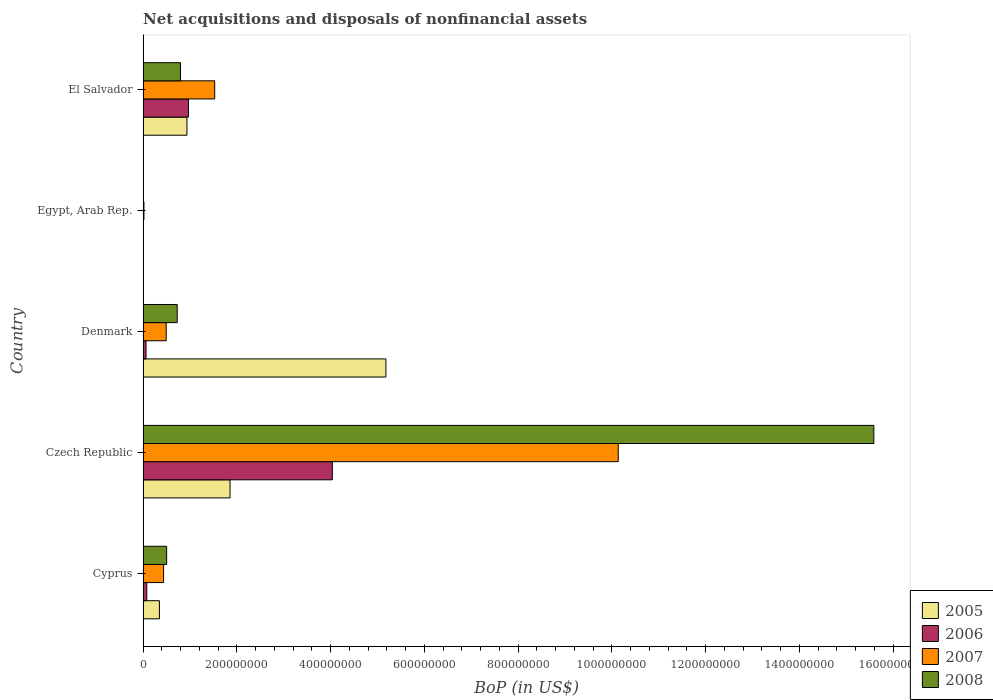How many different coloured bars are there?
Provide a short and direct response. 4. Are the number of bars per tick equal to the number of legend labels?
Keep it short and to the point. No. How many bars are there on the 1st tick from the top?
Keep it short and to the point. 4. How many bars are there on the 2nd tick from the bottom?
Ensure brevity in your answer.  4. What is the label of the 5th group of bars from the top?
Provide a short and direct response. Cyprus. In how many cases, is the number of bars for a given country not equal to the number of legend labels?
Offer a very short reply. 1. Across all countries, what is the maximum Balance of Payments in 2006?
Your answer should be compact. 4.04e+08. Across all countries, what is the minimum Balance of Payments in 2007?
Make the answer very short. 1.90e+06. In which country was the Balance of Payments in 2008 maximum?
Keep it short and to the point. Czech Republic. What is the total Balance of Payments in 2008 in the graph?
Your response must be concise. 1.76e+09. What is the difference between the Balance of Payments in 2007 in Denmark and that in El Salvador?
Your answer should be compact. -1.03e+08. What is the difference between the Balance of Payments in 2006 in Egypt, Arab Rep. and the Balance of Payments in 2008 in El Salvador?
Give a very brief answer. -7.98e+07. What is the average Balance of Payments in 2006 per country?
Offer a very short reply. 1.03e+08. What is the difference between the Balance of Payments in 2006 and Balance of Payments in 2008 in Cyprus?
Your answer should be compact. -4.24e+07. In how many countries, is the Balance of Payments in 2007 greater than 1560000000 US$?
Make the answer very short. 0. What is the ratio of the Balance of Payments in 2008 in Cyprus to that in Denmark?
Ensure brevity in your answer.  0.69. Is the Balance of Payments in 2006 in Czech Republic less than that in Denmark?
Ensure brevity in your answer.  No. Is the difference between the Balance of Payments in 2006 in Czech Republic and El Salvador greater than the difference between the Balance of Payments in 2008 in Czech Republic and El Salvador?
Your answer should be very brief. No. What is the difference between the highest and the second highest Balance of Payments in 2008?
Your answer should be very brief. 1.48e+09. What is the difference between the highest and the lowest Balance of Payments in 2005?
Offer a very short reply. 5.18e+08. Is the sum of the Balance of Payments in 2007 in Denmark and Egypt, Arab Rep. greater than the maximum Balance of Payments in 2005 across all countries?
Keep it short and to the point. No. Are the values on the major ticks of X-axis written in scientific E-notation?
Ensure brevity in your answer.  No. Does the graph contain any zero values?
Give a very brief answer. Yes. Where does the legend appear in the graph?
Your response must be concise. Bottom right. How many legend labels are there?
Make the answer very short. 4. How are the legend labels stacked?
Keep it short and to the point. Vertical. What is the title of the graph?
Provide a succinct answer. Net acquisitions and disposals of nonfinancial assets. What is the label or title of the X-axis?
Your answer should be very brief. BoP (in US$). What is the label or title of the Y-axis?
Provide a short and direct response. Country. What is the BoP (in US$) in 2005 in Cyprus?
Offer a very short reply. 3.49e+07. What is the BoP (in US$) of 2006 in Cyprus?
Provide a short and direct response. 7.90e+06. What is the BoP (in US$) of 2007 in Cyprus?
Keep it short and to the point. 4.38e+07. What is the BoP (in US$) in 2008 in Cyprus?
Your answer should be compact. 5.03e+07. What is the BoP (in US$) in 2005 in Czech Republic?
Give a very brief answer. 1.86e+08. What is the BoP (in US$) in 2006 in Czech Republic?
Offer a very short reply. 4.04e+08. What is the BoP (in US$) of 2007 in Czech Republic?
Your answer should be very brief. 1.01e+09. What is the BoP (in US$) in 2008 in Czech Republic?
Your answer should be compact. 1.56e+09. What is the BoP (in US$) of 2005 in Denmark?
Your answer should be very brief. 5.18e+08. What is the BoP (in US$) of 2006 in Denmark?
Provide a short and direct response. 6.28e+06. What is the BoP (in US$) of 2007 in Denmark?
Your answer should be very brief. 4.93e+07. What is the BoP (in US$) of 2008 in Denmark?
Your answer should be very brief. 7.29e+07. What is the BoP (in US$) of 2005 in Egypt, Arab Rep.?
Offer a terse response. 0. What is the BoP (in US$) of 2006 in Egypt, Arab Rep.?
Provide a short and direct response. 0. What is the BoP (in US$) of 2007 in Egypt, Arab Rep.?
Ensure brevity in your answer.  1.90e+06. What is the BoP (in US$) of 2005 in El Salvador?
Keep it short and to the point. 9.36e+07. What is the BoP (in US$) of 2006 in El Salvador?
Offer a very short reply. 9.68e+07. What is the BoP (in US$) in 2007 in El Salvador?
Make the answer very short. 1.53e+08. What is the BoP (in US$) of 2008 in El Salvador?
Make the answer very short. 7.98e+07. Across all countries, what is the maximum BoP (in US$) of 2005?
Ensure brevity in your answer.  5.18e+08. Across all countries, what is the maximum BoP (in US$) of 2006?
Your response must be concise. 4.04e+08. Across all countries, what is the maximum BoP (in US$) in 2007?
Provide a succinct answer. 1.01e+09. Across all countries, what is the maximum BoP (in US$) in 2008?
Ensure brevity in your answer.  1.56e+09. Across all countries, what is the minimum BoP (in US$) in 2005?
Offer a terse response. 0. Across all countries, what is the minimum BoP (in US$) in 2007?
Keep it short and to the point. 1.90e+06. Across all countries, what is the minimum BoP (in US$) of 2008?
Give a very brief answer. 0. What is the total BoP (in US$) of 2005 in the graph?
Your response must be concise. 8.32e+08. What is the total BoP (in US$) in 2006 in the graph?
Your response must be concise. 5.15e+08. What is the total BoP (in US$) in 2007 in the graph?
Your answer should be compact. 1.26e+09. What is the total BoP (in US$) in 2008 in the graph?
Make the answer very short. 1.76e+09. What is the difference between the BoP (in US$) in 2005 in Cyprus and that in Czech Republic?
Ensure brevity in your answer.  -1.51e+08. What is the difference between the BoP (in US$) of 2006 in Cyprus and that in Czech Republic?
Give a very brief answer. -3.96e+08. What is the difference between the BoP (in US$) of 2007 in Cyprus and that in Czech Republic?
Your response must be concise. -9.70e+08. What is the difference between the BoP (in US$) in 2008 in Cyprus and that in Czech Republic?
Ensure brevity in your answer.  -1.51e+09. What is the difference between the BoP (in US$) in 2005 in Cyprus and that in Denmark?
Provide a short and direct response. -4.83e+08. What is the difference between the BoP (in US$) of 2006 in Cyprus and that in Denmark?
Your answer should be very brief. 1.61e+06. What is the difference between the BoP (in US$) of 2007 in Cyprus and that in Denmark?
Provide a succinct answer. -5.51e+06. What is the difference between the BoP (in US$) of 2008 in Cyprus and that in Denmark?
Ensure brevity in your answer.  -2.26e+07. What is the difference between the BoP (in US$) of 2007 in Cyprus and that in Egypt, Arab Rep.?
Make the answer very short. 4.19e+07. What is the difference between the BoP (in US$) of 2005 in Cyprus and that in El Salvador?
Provide a succinct answer. -5.87e+07. What is the difference between the BoP (in US$) of 2006 in Cyprus and that in El Salvador?
Your answer should be very brief. -8.89e+07. What is the difference between the BoP (in US$) of 2007 in Cyprus and that in El Salvador?
Your answer should be compact. -1.09e+08. What is the difference between the BoP (in US$) of 2008 in Cyprus and that in El Salvador?
Provide a succinct answer. -2.95e+07. What is the difference between the BoP (in US$) of 2005 in Czech Republic and that in Denmark?
Your response must be concise. -3.32e+08. What is the difference between the BoP (in US$) of 2006 in Czech Republic and that in Denmark?
Offer a terse response. 3.97e+08. What is the difference between the BoP (in US$) of 2007 in Czech Republic and that in Denmark?
Your response must be concise. 9.64e+08. What is the difference between the BoP (in US$) of 2008 in Czech Republic and that in Denmark?
Make the answer very short. 1.49e+09. What is the difference between the BoP (in US$) of 2007 in Czech Republic and that in Egypt, Arab Rep.?
Provide a succinct answer. 1.01e+09. What is the difference between the BoP (in US$) in 2005 in Czech Republic and that in El Salvador?
Your answer should be very brief. 9.19e+07. What is the difference between the BoP (in US$) in 2006 in Czech Republic and that in El Salvador?
Provide a short and direct response. 3.07e+08. What is the difference between the BoP (in US$) of 2007 in Czech Republic and that in El Salvador?
Your answer should be very brief. 8.61e+08. What is the difference between the BoP (in US$) of 2008 in Czech Republic and that in El Salvador?
Keep it short and to the point. 1.48e+09. What is the difference between the BoP (in US$) in 2007 in Denmark and that in Egypt, Arab Rep.?
Make the answer very short. 4.74e+07. What is the difference between the BoP (in US$) in 2005 in Denmark and that in El Salvador?
Keep it short and to the point. 4.24e+08. What is the difference between the BoP (in US$) of 2006 in Denmark and that in El Salvador?
Offer a terse response. -9.05e+07. What is the difference between the BoP (in US$) in 2007 in Denmark and that in El Salvador?
Give a very brief answer. -1.03e+08. What is the difference between the BoP (in US$) of 2008 in Denmark and that in El Salvador?
Keep it short and to the point. -6.95e+06. What is the difference between the BoP (in US$) of 2007 in Egypt, Arab Rep. and that in El Salvador?
Give a very brief answer. -1.51e+08. What is the difference between the BoP (in US$) of 2005 in Cyprus and the BoP (in US$) of 2006 in Czech Republic?
Keep it short and to the point. -3.69e+08. What is the difference between the BoP (in US$) of 2005 in Cyprus and the BoP (in US$) of 2007 in Czech Republic?
Ensure brevity in your answer.  -9.79e+08. What is the difference between the BoP (in US$) of 2005 in Cyprus and the BoP (in US$) of 2008 in Czech Republic?
Provide a succinct answer. -1.52e+09. What is the difference between the BoP (in US$) of 2006 in Cyprus and the BoP (in US$) of 2007 in Czech Republic?
Your response must be concise. -1.01e+09. What is the difference between the BoP (in US$) of 2006 in Cyprus and the BoP (in US$) of 2008 in Czech Republic?
Your response must be concise. -1.55e+09. What is the difference between the BoP (in US$) of 2007 in Cyprus and the BoP (in US$) of 2008 in Czech Republic?
Make the answer very short. -1.51e+09. What is the difference between the BoP (in US$) of 2005 in Cyprus and the BoP (in US$) of 2006 in Denmark?
Your answer should be very brief. 2.86e+07. What is the difference between the BoP (in US$) of 2005 in Cyprus and the BoP (in US$) of 2007 in Denmark?
Your answer should be compact. -1.44e+07. What is the difference between the BoP (in US$) of 2005 in Cyprus and the BoP (in US$) of 2008 in Denmark?
Provide a short and direct response. -3.80e+07. What is the difference between the BoP (in US$) in 2006 in Cyprus and the BoP (in US$) in 2007 in Denmark?
Your response must be concise. -4.14e+07. What is the difference between the BoP (in US$) of 2006 in Cyprus and the BoP (in US$) of 2008 in Denmark?
Your answer should be very brief. -6.50e+07. What is the difference between the BoP (in US$) in 2007 in Cyprus and the BoP (in US$) in 2008 in Denmark?
Offer a very short reply. -2.91e+07. What is the difference between the BoP (in US$) in 2005 in Cyprus and the BoP (in US$) in 2007 in Egypt, Arab Rep.?
Offer a very short reply. 3.30e+07. What is the difference between the BoP (in US$) of 2006 in Cyprus and the BoP (in US$) of 2007 in Egypt, Arab Rep.?
Give a very brief answer. 6.00e+06. What is the difference between the BoP (in US$) in 2005 in Cyprus and the BoP (in US$) in 2006 in El Salvador?
Provide a short and direct response. -6.19e+07. What is the difference between the BoP (in US$) in 2005 in Cyprus and the BoP (in US$) in 2007 in El Salvador?
Your answer should be compact. -1.18e+08. What is the difference between the BoP (in US$) in 2005 in Cyprus and the BoP (in US$) in 2008 in El Salvador?
Keep it short and to the point. -4.49e+07. What is the difference between the BoP (in US$) of 2006 in Cyprus and the BoP (in US$) of 2007 in El Salvador?
Give a very brief answer. -1.45e+08. What is the difference between the BoP (in US$) of 2006 in Cyprus and the BoP (in US$) of 2008 in El Salvador?
Keep it short and to the point. -7.19e+07. What is the difference between the BoP (in US$) in 2007 in Cyprus and the BoP (in US$) in 2008 in El Salvador?
Your response must be concise. -3.60e+07. What is the difference between the BoP (in US$) in 2005 in Czech Republic and the BoP (in US$) in 2006 in Denmark?
Provide a succinct answer. 1.79e+08. What is the difference between the BoP (in US$) in 2005 in Czech Republic and the BoP (in US$) in 2007 in Denmark?
Offer a very short reply. 1.36e+08. What is the difference between the BoP (in US$) in 2005 in Czech Republic and the BoP (in US$) in 2008 in Denmark?
Your answer should be very brief. 1.13e+08. What is the difference between the BoP (in US$) of 2006 in Czech Republic and the BoP (in US$) of 2007 in Denmark?
Ensure brevity in your answer.  3.54e+08. What is the difference between the BoP (in US$) in 2006 in Czech Republic and the BoP (in US$) in 2008 in Denmark?
Your answer should be very brief. 3.31e+08. What is the difference between the BoP (in US$) of 2007 in Czech Republic and the BoP (in US$) of 2008 in Denmark?
Your response must be concise. 9.41e+08. What is the difference between the BoP (in US$) of 2005 in Czech Republic and the BoP (in US$) of 2007 in Egypt, Arab Rep.?
Make the answer very short. 1.84e+08. What is the difference between the BoP (in US$) in 2006 in Czech Republic and the BoP (in US$) in 2007 in Egypt, Arab Rep.?
Provide a succinct answer. 4.02e+08. What is the difference between the BoP (in US$) in 2005 in Czech Republic and the BoP (in US$) in 2006 in El Salvador?
Your response must be concise. 8.87e+07. What is the difference between the BoP (in US$) in 2005 in Czech Republic and the BoP (in US$) in 2007 in El Salvador?
Your answer should be very brief. 3.27e+07. What is the difference between the BoP (in US$) of 2005 in Czech Republic and the BoP (in US$) of 2008 in El Salvador?
Offer a very short reply. 1.06e+08. What is the difference between the BoP (in US$) of 2006 in Czech Republic and the BoP (in US$) of 2007 in El Salvador?
Provide a short and direct response. 2.51e+08. What is the difference between the BoP (in US$) of 2006 in Czech Republic and the BoP (in US$) of 2008 in El Salvador?
Offer a very short reply. 3.24e+08. What is the difference between the BoP (in US$) of 2007 in Czech Republic and the BoP (in US$) of 2008 in El Salvador?
Provide a succinct answer. 9.34e+08. What is the difference between the BoP (in US$) in 2005 in Denmark and the BoP (in US$) in 2007 in Egypt, Arab Rep.?
Keep it short and to the point. 5.16e+08. What is the difference between the BoP (in US$) in 2006 in Denmark and the BoP (in US$) in 2007 in Egypt, Arab Rep.?
Keep it short and to the point. 4.38e+06. What is the difference between the BoP (in US$) of 2005 in Denmark and the BoP (in US$) of 2006 in El Salvador?
Make the answer very short. 4.21e+08. What is the difference between the BoP (in US$) in 2005 in Denmark and the BoP (in US$) in 2007 in El Salvador?
Ensure brevity in your answer.  3.65e+08. What is the difference between the BoP (in US$) in 2005 in Denmark and the BoP (in US$) in 2008 in El Salvador?
Give a very brief answer. 4.38e+08. What is the difference between the BoP (in US$) in 2006 in Denmark and the BoP (in US$) in 2007 in El Salvador?
Provide a short and direct response. -1.47e+08. What is the difference between the BoP (in US$) in 2006 in Denmark and the BoP (in US$) in 2008 in El Salvador?
Your response must be concise. -7.35e+07. What is the difference between the BoP (in US$) in 2007 in Denmark and the BoP (in US$) in 2008 in El Salvador?
Make the answer very short. -3.05e+07. What is the difference between the BoP (in US$) of 2007 in Egypt, Arab Rep. and the BoP (in US$) of 2008 in El Salvador?
Make the answer very short. -7.79e+07. What is the average BoP (in US$) in 2005 per country?
Your response must be concise. 1.66e+08. What is the average BoP (in US$) of 2006 per country?
Give a very brief answer. 1.03e+08. What is the average BoP (in US$) in 2007 per country?
Ensure brevity in your answer.  2.52e+08. What is the average BoP (in US$) in 2008 per country?
Provide a succinct answer. 3.52e+08. What is the difference between the BoP (in US$) of 2005 and BoP (in US$) of 2006 in Cyprus?
Your response must be concise. 2.70e+07. What is the difference between the BoP (in US$) in 2005 and BoP (in US$) in 2007 in Cyprus?
Offer a terse response. -8.91e+06. What is the difference between the BoP (in US$) of 2005 and BoP (in US$) of 2008 in Cyprus?
Your answer should be compact. -1.54e+07. What is the difference between the BoP (in US$) in 2006 and BoP (in US$) in 2007 in Cyprus?
Ensure brevity in your answer.  -3.59e+07. What is the difference between the BoP (in US$) of 2006 and BoP (in US$) of 2008 in Cyprus?
Offer a terse response. -4.24e+07. What is the difference between the BoP (in US$) in 2007 and BoP (in US$) in 2008 in Cyprus?
Ensure brevity in your answer.  -6.48e+06. What is the difference between the BoP (in US$) of 2005 and BoP (in US$) of 2006 in Czech Republic?
Your response must be concise. -2.18e+08. What is the difference between the BoP (in US$) in 2005 and BoP (in US$) in 2007 in Czech Republic?
Offer a terse response. -8.28e+08. What is the difference between the BoP (in US$) of 2005 and BoP (in US$) of 2008 in Czech Republic?
Your answer should be very brief. -1.37e+09. What is the difference between the BoP (in US$) in 2006 and BoP (in US$) in 2007 in Czech Republic?
Offer a very short reply. -6.10e+08. What is the difference between the BoP (in US$) in 2006 and BoP (in US$) in 2008 in Czech Republic?
Ensure brevity in your answer.  -1.15e+09. What is the difference between the BoP (in US$) in 2007 and BoP (in US$) in 2008 in Czech Republic?
Offer a terse response. -5.45e+08. What is the difference between the BoP (in US$) in 2005 and BoP (in US$) in 2006 in Denmark?
Provide a short and direct response. 5.12e+08. What is the difference between the BoP (in US$) in 2005 and BoP (in US$) in 2007 in Denmark?
Ensure brevity in your answer.  4.69e+08. What is the difference between the BoP (in US$) of 2005 and BoP (in US$) of 2008 in Denmark?
Ensure brevity in your answer.  4.45e+08. What is the difference between the BoP (in US$) in 2006 and BoP (in US$) in 2007 in Denmark?
Your answer should be compact. -4.30e+07. What is the difference between the BoP (in US$) of 2006 and BoP (in US$) of 2008 in Denmark?
Your answer should be compact. -6.66e+07. What is the difference between the BoP (in US$) in 2007 and BoP (in US$) in 2008 in Denmark?
Your answer should be compact. -2.35e+07. What is the difference between the BoP (in US$) of 2005 and BoP (in US$) of 2006 in El Salvador?
Offer a terse response. -3.20e+06. What is the difference between the BoP (in US$) in 2005 and BoP (in US$) in 2007 in El Salvador?
Give a very brief answer. -5.92e+07. What is the difference between the BoP (in US$) of 2005 and BoP (in US$) of 2008 in El Salvador?
Your answer should be compact. 1.38e+07. What is the difference between the BoP (in US$) in 2006 and BoP (in US$) in 2007 in El Salvador?
Provide a short and direct response. -5.60e+07. What is the difference between the BoP (in US$) in 2006 and BoP (in US$) in 2008 in El Salvador?
Make the answer very short. 1.70e+07. What is the difference between the BoP (in US$) of 2007 and BoP (in US$) of 2008 in El Salvador?
Ensure brevity in your answer.  7.30e+07. What is the ratio of the BoP (in US$) of 2005 in Cyprus to that in Czech Republic?
Keep it short and to the point. 0.19. What is the ratio of the BoP (in US$) in 2006 in Cyprus to that in Czech Republic?
Your response must be concise. 0.02. What is the ratio of the BoP (in US$) in 2007 in Cyprus to that in Czech Republic?
Keep it short and to the point. 0.04. What is the ratio of the BoP (in US$) of 2008 in Cyprus to that in Czech Republic?
Provide a short and direct response. 0.03. What is the ratio of the BoP (in US$) of 2005 in Cyprus to that in Denmark?
Your response must be concise. 0.07. What is the ratio of the BoP (in US$) of 2006 in Cyprus to that in Denmark?
Ensure brevity in your answer.  1.26. What is the ratio of the BoP (in US$) in 2007 in Cyprus to that in Denmark?
Your answer should be compact. 0.89. What is the ratio of the BoP (in US$) of 2008 in Cyprus to that in Denmark?
Offer a terse response. 0.69. What is the ratio of the BoP (in US$) of 2007 in Cyprus to that in Egypt, Arab Rep.?
Offer a terse response. 23.05. What is the ratio of the BoP (in US$) of 2005 in Cyprus to that in El Salvador?
Make the answer very short. 0.37. What is the ratio of the BoP (in US$) in 2006 in Cyprus to that in El Salvador?
Offer a very short reply. 0.08. What is the ratio of the BoP (in US$) in 2007 in Cyprus to that in El Salvador?
Your response must be concise. 0.29. What is the ratio of the BoP (in US$) of 2008 in Cyprus to that in El Salvador?
Your answer should be very brief. 0.63. What is the ratio of the BoP (in US$) in 2005 in Czech Republic to that in Denmark?
Provide a short and direct response. 0.36. What is the ratio of the BoP (in US$) of 2006 in Czech Republic to that in Denmark?
Provide a short and direct response. 64.27. What is the ratio of the BoP (in US$) in 2007 in Czech Republic to that in Denmark?
Your response must be concise. 20.55. What is the ratio of the BoP (in US$) in 2008 in Czech Republic to that in Denmark?
Provide a succinct answer. 21.39. What is the ratio of the BoP (in US$) of 2007 in Czech Republic to that in Egypt, Arab Rep.?
Provide a short and direct response. 533.43. What is the ratio of the BoP (in US$) of 2005 in Czech Republic to that in El Salvador?
Give a very brief answer. 1.98. What is the ratio of the BoP (in US$) of 2006 in Czech Republic to that in El Salvador?
Offer a terse response. 4.17. What is the ratio of the BoP (in US$) of 2007 in Czech Republic to that in El Salvador?
Your response must be concise. 6.63. What is the ratio of the BoP (in US$) of 2008 in Czech Republic to that in El Salvador?
Provide a succinct answer. 19.53. What is the ratio of the BoP (in US$) of 2007 in Denmark to that in Egypt, Arab Rep.?
Make the answer very short. 25.95. What is the ratio of the BoP (in US$) in 2005 in Denmark to that in El Salvador?
Ensure brevity in your answer.  5.53. What is the ratio of the BoP (in US$) in 2006 in Denmark to that in El Salvador?
Ensure brevity in your answer.  0.06. What is the ratio of the BoP (in US$) of 2007 in Denmark to that in El Salvador?
Give a very brief answer. 0.32. What is the ratio of the BoP (in US$) of 2008 in Denmark to that in El Salvador?
Make the answer very short. 0.91. What is the ratio of the BoP (in US$) in 2007 in Egypt, Arab Rep. to that in El Salvador?
Keep it short and to the point. 0.01. What is the difference between the highest and the second highest BoP (in US$) in 2005?
Provide a short and direct response. 3.32e+08. What is the difference between the highest and the second highest BoP (in US$) of 2006?
Your response must be concise. 3.07e+08. What is the difference between the highest and the second highest BoP (in US$) of 2007?
Your answer should be compact. 8.61e+08. What is the difference between the highest and the second highest BoP (in US$) in 2008?
Ensure brevity in your answer.  1.48e+09. What is the difference between the highest and the lowest BoP (in US$) in 2005?
Give a very brief answer. 5.18e+08. What is the difference between the highest and the lowest BoP (in US$) in 2006?
Keep it short and to the point. 4.04e+08. What is the difference between the highest and the lowest BoP (in US$) in 2007?
Provide a short and direct response. 1.01e+09. What is the difference between the highest and the lowest BoP (in US$) in 2008?
Offer a very short reply. 1.56e+09. 